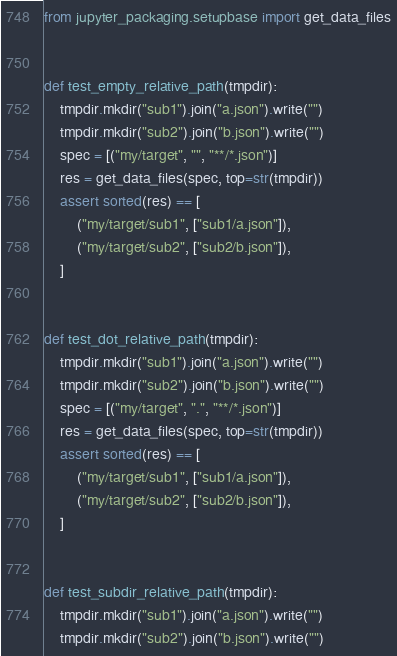Convert code to text. <code><loc_0><loc_0><loc_500><loc_500><_Python_>from jupyter_packaging.setupbase import get_data_files


def test_empty_relative_path(tmpdir):
    tmpdir.mkdir("sub1").join("a.json").write("")
    tmpdir.mkdir("sub2").join("b.json").write("")
    spec = [("my/target", "", "**/*.json")]
    res = get_data_files(spec, top=str(tmpdir))
    assert sorted(res) == [
        ("my/target/sub1", ["sub1/a.json"]),
        ("my/target/sub2", ["sub2/b.json"]),
    ]


def test_dot_relative_path(tmpdir):
    tmpdir.mkdir("sub1").join("a.json").write("")
    tmpdir.mkdir("sub2").join("b.json").write("")
    spec = [("my/target", ".", "**/*.json")]
    res = get_data_files(spec, top=str(tmpdir))
    assert sorted(res) == [
        ("my/target/sub1", ["sub1/a.json"]),
        ("my/target/sub2", ["sub2/b.json"]),
    ]


def test_subdir_relative_path(tmpdir):
    tmpdir.mkdir("sub1").join("a.json").write("")
    tmpdir.mkdir("sub2").join("b.json").write("")</code> 